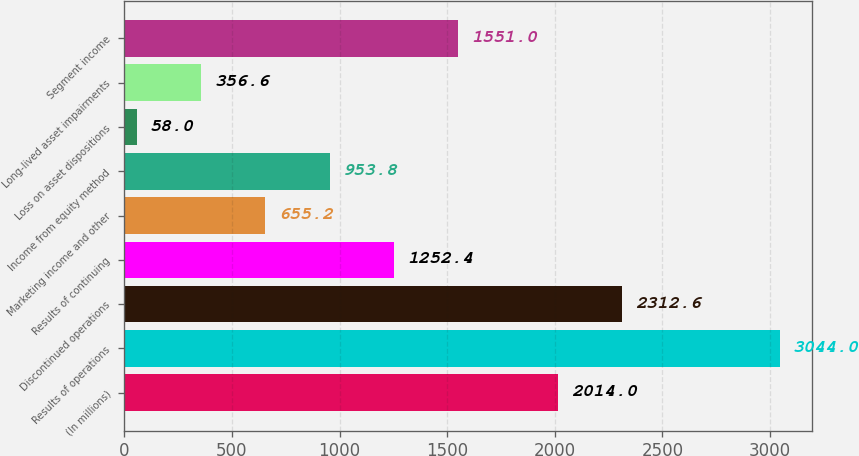<chart> <loc_0><loc_0><loc_500><loc_500><bar_chart><fcel>(In millions)<fcel>Results of operations<fcel>Discontinued operations<fcel>Results of continuing<fcel>Marketing income and other<fcel>Income from equity method<fcel>Loss on asset dispositions<fcel>Long-lived asset impairments<fcel>Segment income<nl><fcel>2014<fcel>3044<fcel>2312.6<fcel>1252.4<fcel>655.2<fcel>953.8<fcel>58<fcel>356.6<fcel>1551<nl></chart> 